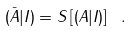Convert formula to latex. <formula><loc_0><loc_0><loc_500><loc_500>( \bar { A } | I ) = S \left [ ( A | I ) \right ] \ .</formula> 